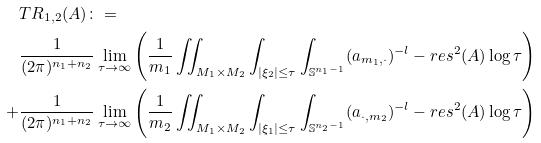<formula> <loc_0><loc_0><loc_500><loc_500>& T R _ { 1 , 2 } ( A ) \colon = \\ & \frac { 1 } { ( 2 \pi ) ^ { n _ { 1 } + n _ { 2 } } } \lim _ { \tau \to \infty } \left ( \frac { 1 } { m _ { 1 } } \iint _ { M _ { 1 } \times M _ { 2 } } \int _ { | \xi _ { 2 } | \leq \tau } \int _ { \mathbb { S } ^ { n _ { 1 } - 1 } } ( a _ { m _ { 1 } , \cdot } ) ^ { - l } - r e s ^ { 2 } ( A ) \log \tau \right ) \\ + & \frac { 1 } { ( 2 \pi ) ^ { n _ { 1 } + n _ { 2 } } } \lim _ { \tau \to \infty } \left ( \frac { 1 } { m _ { 2 } } \iint _ { M _ { 1 } \times M _ { 2 } } \int _ { | \xi _ { 1 } | \leq \tau } \int _ { \mathbb { S } ^ { n _ { 2 } - 1 } } ( a _ { \cdot , m _ { 2 } } ) ^ { - l } - r e s ^ { 2 } ( A ) \log \tau \right )</formula> 